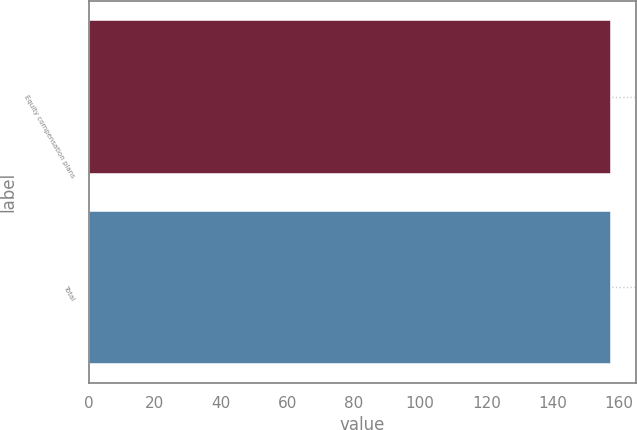<chart> <loc_0><loc_0><loc_500><loc_500><bar_chart><fcel>Equity compensation plans<fcel>Total<nl><fcel>157.25<fcel>157.35<nl></chart> 